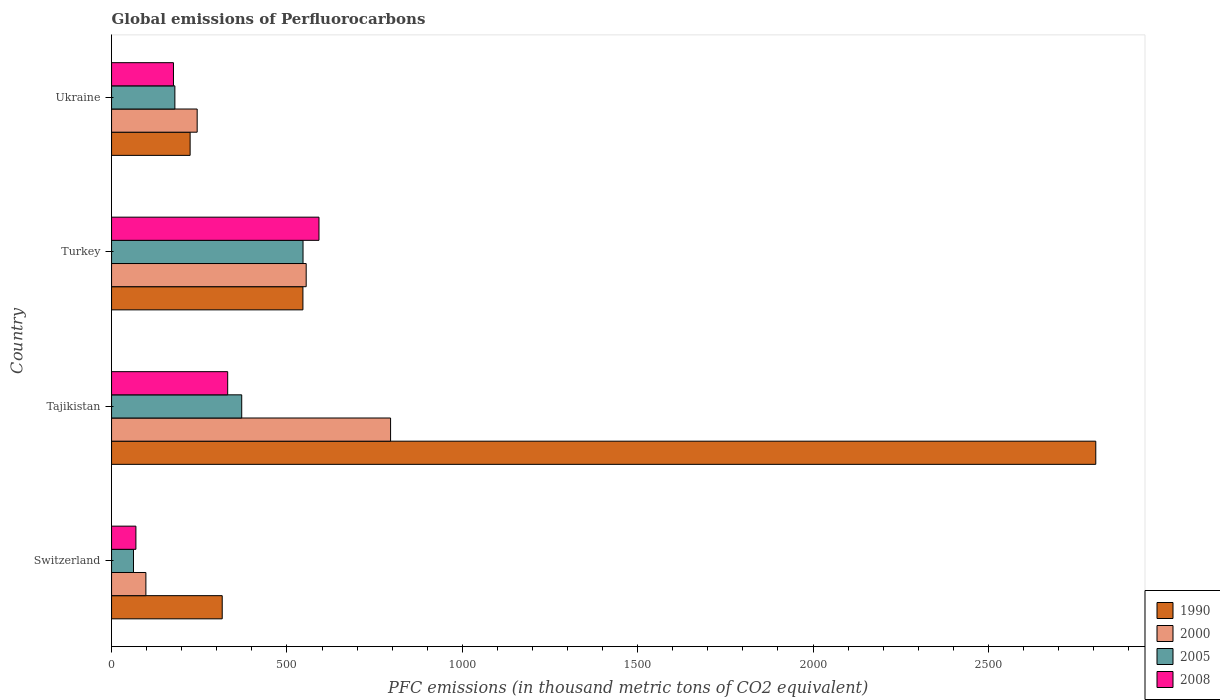How many different coloured bars are there?
Make the answer very short. 4. How many groups of bars are there?
Give a very brief answer. 4. Are the number of bars per tick equal to the number of legend labels?
Give a very brief answer. Yes. How many bars are there on the 1st tick from the bottom?
Offer a very short reply. 4. What is the label of the 4th group of bars from the top?
Ensure brevity in your answer.  Switzerland. In how many cases, is the number of bars for a given country not equal to the number of legend labels?
Offer a terse response. 0. What is the global emissions of Perfluorocarbons in 2005 in Tajikistan?
Make the answer very short. 371.1. Across all countries, what is the maximum global emissions of Perfluorocarbons in 1990?
Your answer should be compact. 2806.1. Across all countries, what is the minimum global emissions of Perfluorocarbons in 2005?
Provide a short and direct response. 62.5. In which country was the global emissions of Perfluorocarbons in 1990 maximum?
Provide a succinct answer. Tajikistan. In which country was the global emissions of Perfluorocarbons in 1990 minimum?
Offer a terse response. Ukraine. What is the total global emissions of Perfluorocarbons in 2008 in the graph?
Provide a short and direct response. 1168.4. What is the difference between the global emissions of Perfluorocarbons in 1990 in Turkey and that in Ukraine?
Offer a very short reply. 321.6. What is the difference between the global emissions of Perfluorocarbons in 1990 in Ukraine and the global emissions of Perfluorocarbons in 2005 in Turkey?
Provide a succinct answer. -321.9. What is the average global emissions of Perfluorocarbons in 2000 per country?
Provide a short and direct response. 423.1. What is the difference between the global emissions of Perfluorocarbons in 2005 and global emissions of Perfluorocarbons in 1990 in Turkey?
Offer a very short reply. 0.3. What is the ratio of the global emissions of Perfluorocarbons in 2000 in Switzerland to that in Ukraine?
Your answer should be compact. 0.4. Is the global emissions of Perfluorocarbons in 2005 in Switzerland less than that in Tajikistan?
Give a very brief answer. Yes. What is the difference between the highest and the second highest global emissions of Perfluorocarbons in 2008?
Your response must be concise. 260.3. What is the difference between the highest and the lowest global emissions of Perfluorocarbons in 2008?
Make the answer very short. 522. Is the sum of the global emissions of Perfluorocarbons in 1990 in Switzerland and Ukraine greater than the maximum global emissions of Perfluorocarbons in 2005 across all countries?
Provide a short and direct response. No. What does the 1st bar from the top in Turkey represents?
Your answer should be compact. 2008. Is it the case that in every country, the sum of the global emissions of Perfluorocarbons in 2000 and global emissions of Perfluorocarbons in 2008 is greater than the global emissions of Perfluorocarbons in 2005?
Your answer should be compact. Yes. How many bars are there?
Your answer should be very brief. 16. How many countries are there in the graph?
Give a very brief answer. 4. Does the graph contain grids?
Provide a short and direct response. No. Where does the legend appear in the graph?
Provide a short and direct response. Bottom right. How are the legend labels stacked?
Offer a very short reply. Vertical. What is the title of the graph?
Provide a succinct answer. Global emissions of Perfluorocarbons. What is the label or title of the X-axis?
Your answer should be compact. PFC emissions (in thousand metric tons of CO2 equivalent). What is the label or title of the Y-axis?
Ensure brevity in your answer.  Country. What is the PFC emissions (in thousand metric tons of CO2 equivalent) of 1990 in Switzerland?
Offer a very short reply. 315.5. What is the PFC emissions (in thousand metric tons of CO2 equivalent) of 2000 in Switzerland?
Make the answer very short. 97.9. What is the PFC emissions (in thousand metric tons of CO2 equivalent) in 2005 in Switzerland?
Provide a short and direct response. 62.5. What is the PFC emissions (in thousand metric tons of CO2 equivalent) in 2008 in Switzerland?
Your response must be concise. 69.4. What is the PFC emissions (in thousand metric tons of CO2 equivalent) of 1990 in Tajikistan?
Your answer should be very brief. 2806.1. What is the PFC emissions (in thousand metric tons of CO2 equivalent) in 2000 in Tajikistan?
Provide a succinct answer. 795.5. What is the PFC emissions (in thousand metric tons of CO2 equivalent) in 2005 in Tajikistan?
Make the answer very short. 371.1. What is the PFC emissions (in thousand metric tons of CO2 equivalent) in 2008 in Tajikistan?
Keep it short and to the point. 331.1. What is the PFC emissions (in thousand metric tons of CO2 equivalent) of 1990 in Turkey?
Provide a succinct answer. 545.6. What is the PFC emissions (in thousand metric tons of CO2 equivalent) of 2000 in Turkey?
Ensure brevity in your answer.  554.9. What is the PFC emissions (in thousand metric tons of CO2 equivalent) in 2005 in Turkey?
Provide a succinct answer. 545.9. What is the PFC emissions (in thousand metric tons of CO2 equivalent) of 2008 in Turkey?
Provide a short and direct response. 591.4. What is the PFC emissions (in thousand metric tons of CO2 equivalent) in 1990 in Ukraine?
Keep it short and to the point. 224. What is the PFC emissions (in thousand metric tons of CO2 equivalent) in 2000 in Ukraine?
Keep it short and to the point. 244.1. What is the PFC emissions (in thousand metric tons of CO2 equivalent) of 2005 in Ukraine?
Offer a very short reply. 180.5. What is the PFC emissions (in thousand metric tons of CO2 equivalent) of 2008 in Ukraine?
Your answer should be very brief. 176.5. Across all countries, what is the maximum PFC emissions (in thousand metric tons of CO2 equivalent) of 1990?
Provide a succinct answer. 2806.1. Across all countries, what is the maximum PFC emissions (in thousand metric tons of CO2 equivalent) in 2000?
Make the answer very short. 795.5. Across all countries, what is the maximum PFC emissions (in thousand metric tons of CO2 equivalent) of 2005?
Keep it short and to the point. 545.9. Across all countries, what is the maximum PFC emissions (in thousand metric tons of CO2 equivalent) of 2008?
Offer a terse response. 591.4. Across all countries, what is the minimum PFC emissions (in thousand metric tons of CO2 equivalent) in 1990?
Offer a terse response. 224. Across all countries, what is the minimum PFC emissions (in thousand metric tons of CO2 equivalent) in 2000?
Make the answer very short. 97.9. Across all countries, what is the minimum PFC emissions (in thousand metric tons of CO2 equivalent) in 2005?
Keep it short and to the point. 62.5. Across all countries, what is the minimum PFC emissions (in thousand metric tons of CO2 equivalent) of 2008?
Keep it short and to the point. 69.4. What is the total PFC emissions (in thousand metric tons of CO2 equivalent) in 1990 in the graph?
Give a very brief answer. 3891.2. What is the total PFC emissions (in thousand metric tons of CO2 equivalent) in 2000 in the graph?
Your response must be concise. 1692.4. What is the total PFC emissions (in thousand metric tons of CO2 equivalent) in 2005 in the graph?
Your answer should be compact. 1160. What is the total PFC emissions (in thousand metric tons of CO2 equivalent) of 2008 in the graph?
Provide a succinct answer. 1168.4. What is the difference between the PFC emissions (in thousand metric tons of CO2 equivalent) in 1990 in Switzerland and that in Tajikistan?
Provide a short and direct response. -2490.6. What is the difference between the PFC emissions (in thousand metric tons of CO2 equivalent) of 2000 in Switzerland and that in Tajikistan?
Offer a very short reply. -697.6. What is the difference between the PFC emissions (in thousand metric tons of CO2 equivalent) of 2005 in Switzerland and that in Tajikistan?
Your answer should be very brief. -308.6. What is the difference between the PFC emissions (in thousand metric tons of CO2 equivalent) in 2008 in Switzerland and that in Tajikistan?
Make the answer very short. -261.7. What is the difference between the PFC emissions (in thousand metric tons of CO2 equivalent) of 1990 in Switzerland and that in Turkey?
Make the answer very short. -230.1. What is the difference between the PFC emissions (in thousand metric tons of CO2 equivalent) in 2000 in Switzerland and that in Turkey?
Provide a succinct answer. -457. What is the difference between the PFC emissions (in thousand metric tons of CO2 equivalent) in 2005 in Switzerland and that in Turkey?
Make the answer very short. -483.4. What is the difference between the PFC emissions (in thousand metric tons of CO2 equivalent) of 2008 in Switzerland and that in Turkey?
Give a very brief answer. -522. What is the difference between the PFC emissions (in thousand metric tons of CO2 equivalent) of 1990 in Switzerland and that in Ukraine?
Provide a short and direct response. 91.5. What is the difference between the PFC emissions (in thousand metric tons of CO2 equivalent) in 2000 in Switzerland and that in Ukraine?
Give a very brief answer. -146.2. What is the difference between the PFC emissions (in thousand metric tons of CO2 equivalent) of 2005 in Switzerland and that in Ukraine?
Give a very brief answer. -118. What is the difference between the PFC emissions (in thousand metric tons of CO2 equivalent) of 2008 in Switzerland and that in Ukraine?
Your response must be concise. -107.1. What is the difference between the PFC emissions (in thousand metric tons of CO2 equivalent) of 1990 in Tajikistan and that in Turkey?
Keep it short and to the point. 2260.5. What is the difference between the PFC emissions (in thousand metric tons of CO2 equivalent) in 2000 in Tajikistan and that in Turkey?
Make the answer very short. 240.6. What is the difference between the PFC emissions (in thousand metric tons of CO2 equivalent) of 2005 in Tajikistan and that in Turkey?
Give a very brief answer. -174.8. What is the difference between the PFC emissions (in thousand metric tons of CO2 equivalent) of 2008 in Tajikistan and that in Turkey?
Make the answer very short. -260.3. What is the difference between the PFC emissions (in thousand metric tons of CO2 equivalent) in 1990 in Tajikistan and that in Ukraine?
Provide a short and direct response. 2582.1. What is the difference between the PFC emissions (in thousand metric tons of CO2 equivalent) in 2000 in Tajikistan and that in Ukraine?
Offer a very short reply. 551.4. What is the difference between the PFC emissions (in thousand metric tons of CO2 equivalent) in 2005 in Tajikistan and that in Ukraine?
Your answer should be very brief. 190.6. What is the difference between the PFC emissions (in thousand metric tons of CO2 equivalent) of 2008 in Tajikistan and that in Ukraine?
Make the answer very short. 154.6. What is the difference between the PFC emissions (in thousand metric tons of CO2 equivalent) of 1990 in Turkey and that in Ukraine?
Your answer should be compact. 321.6. What is the difference between the PFC emissions (in thousand metric tons of CO2 equivalent) of 2000 in Turkey and that in Ukraine?
Offer a very short reply. 310.8. What is the difference between the PFC emissions (in thousand metric tons of CO2 equivalent) of 2005 in Turkey and that in Ukraine?
Keep it short and to the point. 365.4. What is the difference between the PFC emissions (in thousand metric tons of CO2 equivalent) in 2008 in Turkey and that in Ukraine?
Keep it short and to the point. 414.9. What is the difference between the PFC emissions (in thousand metric tons of CO2 equivalent) in 1990 in Switzerland and the PFC emissions (in thousand metric tons of CO2 equivalent) in 2000 in Tajikistan?
Your answer should be very brief. -480. What is the difference between the PFC emissions (in thousand metric tons of CO2 equivalent) of 1990 in Switzerland and the PFC emissions (in thousand metric tons of CO2 equivalent) of 2005 in Tajikistan?
Offer a terse response. -55.6. What is the difference between the PFC emissions (in thousand metric tons of CO2 equivalent) of 1990 in Switzerland and the PFC emissions (in thousand metric tons of CO2 equivalent) of 2008 in Tajikistan?
Provide a succinct answer. -15.6. What is the difference between the PFC emissions (in thousand metric tons of CO2 equivalent) of 2000 in Switzerland and the PFC emissions (in thousand metric tons of CO2 equivalent) of 2005 in Tajikistan?
Offer a terse response. -273.2. What is the difference between the PFC emissions (in thousand metric tons of CO2 equivalent) in 2000 in Switzerland and the PFC emissions (in thousand metric tons of CO2 equivalent) in 2008 in Tajikistan?
Ensure brevity in your answer.  -233.2. What is the difference between the PFC emissions (in thousand metric tons of CO2 equivalent) in 2005 in Switzerland and the PFC emissions (in thousand metric tons of CO2 equivalent) in 2008 in Tajikistan?
Make the answer very short. -268.6. What is the difference between the PFC emissions (in thousand metric tons of CO2 equivalent) in 1990 in Switzerland and the PFC emissions (in thousand metric tons of CO2 equivalent) in 2000 in Turkey?
Offer a very short reply. -239.4. What is the difference between the PFC emissions (in thousand metric tons of CO2 equivalent) of 1990 in Switzerland and the PFC emissions (in thousand metric tons of CO2 equivalent) of 2005 in Turkey?
Your answer should be compact. -230.4. What is the difference between the PFC emissions (in thousand metric tons of CO2 equivalent) in 1990 in Switzerland and the PFC emissions (in thousand metric tons of CO2 equivalent) in 2008 in Turkey?
Give a very brief answer. -275.9. What is the difference between the PFC emissions (in thousand metric tons of CO2 equivalent) in 2000 in Switzerland and the PFC emissions (in thousand metric tons of CO2 equivalent) in 2005 in Turkey?
Your answer should be compact. -448. What is the difference between the PFC emissions (in thousand metric tons of CO2 equivalent) of 2000 in Switzerland and the PFC emissions (in thousand metric tons of CO2 equivalent) of 2008 in Turkey?
Provide a succinct answer. -493.5. What is the difference between the PFC emissions (in thousand metric tons of CO2 equivalent) in 2005 in Switzerland and the PFC emissions (in thousand metric tons of CO2 equivalent) in 2008 in Turkey?
Your answer should be very brief. -528.9. What is the difference between the PFC emissions (in thousand metric tons of CO2 equivalent) of 1990 in Switzerland and the PFC emissions (in thousand metric tons of CO2 equivalent) of 2000 in Ukraine?
Your answer should be compact. 71.4. What is the difference between the PFC emissions (in thousand metric tons of CO2 equivalent) of 1990 in Switzerland and the PFC emissions (in thousand metric tons of CO2 equivalent) of 2005 in Ukraine?
Ensure brevity in your answer.  135. What is the difference between the PFC emissions (in thousand metric tons of CO2 equivalent) of 1990 in Switzerland and the PFC emissions (in thousand metric tons of CO2 equivalent) of 2008 in Ukraine?
Offer a terse response. 139. What is the difference between the PFC emissions (in thousand metric tons of CO2 equivalent) of 2000 in Switzerland and the PFC emissions (in thousand metric tons of CO2 equivalent) of 2005 in Ukraine?
Your answer should be very brief. -82.6. What is the difference between the PFC emissions (in thousand metric tons of CO2 equivalent) in 2000 in Switzerland and the PFC emissions (in thousand metric tons of CO2 equivalent) in 2008 in Ukraine?
Offer a very short reply. -78.6. What is the difference between the PFC emissions (in thousand metric tons of CO2 equivalent) of 2005 in Switzerland and the PFC emissions (in thousand metric tons of CO2 equivalent) of 2008 in Ukraine?
Your response must be concise. -114. What is the difference between the PFC emissions (in thousand metric tons of CO2 equivalent) of 1990 in Tajikistan and the PFC emissions (in thousand metric tons of CO2 equivalent) of 2000 in Turkey?
Your answer should be very brief. 2251.2. What is the difference between the PFC emissions (in thousand metric tons of CO2 equivalent) in 1990 in Tajikistan and the PFC emissions (in thousand metric tons of CO2 equivalent) in 2005 in Turkey?
Your response must be concise. 2260.2. What is the difference between the PFC emissions (in thousand metric tons of CO2 equivalent) in 1990 in Tajikistan and the PFC emissions (in thousand metric tons of CO2 equivalent) in 2008 in Turkey?
Ensure brevity in your answer.  2214.7. What is the difference between the PFC emissions (in thousand metric tons of CO2 equivalent) of 2000 in Tajikistan and the PFC emissions (in thousand metric tons of CO2 equivalent) of 2005 in Turkey?
Your answer should be very brief. 249.6. What is the difference between the PFC emissions (in thousand metric tons of CO2 equivalent) in 2000 in Tajikistan and the PFC emissions (in thousand metric tons of CO2 equivalent) in 2008 in Turkey?
Your answer should be very brief. 204.1. What is the difference between the PFC emissions (in thousand metric tons of CO2 equivalent) in 2005 in Tajikistan and the PFC emissions (in thousand metric tons of CO2 equivalent) in 2008 in Turkey?
Your answer should be compact. -220.3. What is the difference between the PFC emissions (in thousand metric tons of CO2 equivalent) of 1990 in Tajikistan and the PFC emissions (in thousand metric tons of CO2 equivalent) of 2000 in Ukraine?
Your answer should be very brief. 2562. What is the difference between the PFC emissions (in thousand metric tons of CO2 equivalent) of 1990 in Tajikistan and the PFC emissions (in thousand metric tons of CO2 equivalent) of 2005 in Ukraine?
Provide a succinct answer. 2625.6. What is the difference between the PFC emissions (in thousand metric tons of CO2 equivalent) in 1990 in Tajikistan and the PFC emissions (in thousand metric tons of CO2 equivalent) in 2008 in Ukraine?
Provide a short and direct response. 2629.6. What is the difference between the PFC emissions (in thousand metric tons of CO2 equivalent) of 2000 in Tajikistan and the PFC emissions (in thousand metric tons of CO2 equivalent) of 2005 in Ukraine?
Keep it short and to the point. 615. What is the difference between the PFC emissions (in thousand metric tons of CO2 equivalent) of 2000 in Tajikistan and the PFC emissions (in thousand metric tons of CO2 equivalent) of 2008 in Ukraine?
Offer a very short reply. 619. What is the difference between the PFC emissions (in thousand metric tons of CO2 equivalent) of 2005 in Tajikistan and the PFC emissions (in thousand metric tons of CO2 equivalent) of 2008 in Ukraine?
Your answer should be very brief. 194.6. What is the difference between the PFC emissions (in thousand metric tons of CO2 equivalent) in 1990 in Turkey and the PFC emissions (in thousand metric tons of CO2 equivalent) in 2000 in Ukraine?
Ensure brevity in your answer.  301.5. What is the difference between the PFC emissions (in thousand metric tons of CO2 equivalent) of 1990 in Turkey and the PFC emissions (in thousand metric tons of CO2 equivalent) of 2005 in Ukraine?
Offer a very short reply. 365.1. What is the difference between the PFC emissions (in thousand metric tons of CO2 equivalent) in 1990 in Turkey and the PFC emissions (in thousand metric tons of CO2 equivalent) in 2008 in Ukraine?
Your answer should be compact. 369.1. What is the difference between the PFC emissions (in thousand metric tons of CO2 equivalent) of 2000 in Turkey and the PFC emissions (in thousand metric tons of CO2 equivalent) of 2005 in Ukraine?
Give a very brief answer. 374.4. What is the difference between the PFC emissions (in thousand metric tons of CO2 equivalent) in 2000 in Turkey and the PFC emissions (in thousand metric tons of CO2 equivalent) in 2008 in Ukraine?
Give a very brief answer. 378.4. What is the difference between the PFC emissions (in thousand metric tons of CO2 equivalent) in 2005 in Turkey and the PFC emissions (in thousand metric tons of CO2 equivalent) in 2008 in Ukraine?
Your response must be concise. 369.4. What is the average PFC emissions (in thousand metric tons of CO2 equivalent) of 1990 per country?
Keep it short and to the point. 972.8. What is the average PFC emissions (in thousand metric tons of CO2 equivalent) of 2000 per country?
Your answer should be very brief. 423.1. What is the average PFC emissions (in thousand metric tons of CO2 equivalent) in 2005 per country?
Offer a very short reply. 290. What is the average PFC emissions (in thousand metric tons of CO2 equivalent) of 2008 per country?
Give a very brief answer. 292.1. What is the difference between the PFC emissions (in thousand metric tons of CO2 equivalent) in 1990 and PFC emissions (in thousand metric tons of CO2 equivalent) in 2000 in Switzerland?
Offer a very short reply. 217.6. What is the difference between the PFC emissions (in thousand metric tons of CO2 equivalent) of 1990 and PFC emissions (in thousand metric tons of CO2 equivalent) of 2005 in Switzerland?
Your answer should be very brief. 253. What is the difference between the PFC emissions (in thousand metric tons of CO2 equivalent) in 1990 and PFC emissions (in thousand metric tons of CO2 equivalent) in 2008 in Switzerland?
Provide a short and direct response. 246.1. What is the difference between the PFC emissions (in thousand metric tons of CO2 equivalent) of 2000 and PFC emissions (in thousand metric tons of CO2 equivalent) of 2005 in Switzerland?
Provide a short and direct response. 35.4. What is the difference between the PFC emissions (in thousand metric tons of CO2 equivalent) of 2005 and PFC emissions (in thousand metric tons of CO2 equivalent) of 2008 in Switzerland?
Your response must be concise. -6.9. What is the difference between the PFC emissions (in thousand metric tons of CO2 equivalent) of 1990 and PFC emissions (in thousand metric tons of CO2 equivalent) of 2000 in Tajikistan?
Your answer should be compact. 2010.6. What is the difference between the PFC emissions (in thousand metric tons of CO2 equivalent) in 1990 and PFC emissions (in thousand metric tons of CO2 equivalent) in 2005 in Tajikistan?
Offer a terse response. 2435. What is the difference between the PFC emissions (in thousand metric tons of CO2 equivalent) of 1990 and PFC emissions (in thousand metric tons of CO2 equivalent) of 2008 in Tajikistan?
Give a very brief answer. 2475. What is the difference between the PFC emissions (in thousand metric tons of CO2 equivalent) in 2000 and PFC emissions (in thousand metric tons of CO2 equivalent) in 2005 in Tajikistan?
Give a very brief answer. 424.4. What is the difference between the PFC emissions (in thousand metric tons of CO2 equivalent) in 2000 and PFC emissions (in thousand metric tons of CO2 equivalent) in 2008 in Tajikistan?
Offer a terse response. 464.4. What is the difference between the PFC emissions (in thousand metric tons of CO2 equivalent) of 1990 and PFC emissions (in thousand metric tons of CO2 equivalent) of 2005 in Turkey?
Your answer should be very brief. -0.3. What is the difference between the PFC emissions (in thousand metric tons of CO2 equivalent) in 1990 and PFC emissions (in thousand metric tons of CO2 equivalent) in 2008 in Turkey?
Keep it short and to the point. -45.8. What is the difference between the PFC emissions (in thousand metric tons of CO2 equivalent) in 2000 and PFC emissions (in thousand metric tons of CO2 equivalent) in 2005 in Turkey?
Your answer should be very brief. 9. What is the difference between the PFC emissions (in thousand metric tons of CO2 equivalent) in 2000 and PFC emissions (in thousand metric tons of CO2 equivalent) in 2008 in Turkey?
Provide a short and direct response. -36.5. What is the difference between the PFC emissions (in thousand metric tons of CO2 equivalent) of 2005 and PFC emissions (in thousand metric tons of CO2 equivalent) of 2008 in Turkey?
Keep it short and to the point. -45.5. What is the difference between the PFC emissions (in thousand metric tons of CO2 equivalent) of 1990 and PFC emissions (in thousand metric tons of CO2 equivalent) of 2000 in Ukraine?
Your answer should be compact. -20.1. What is the difference between the PFC emissions (in thousand metric tons of CO2 equivalent) in 1990 and PFC emissions (in thousand metric tons of CO2 equivalent) in 2005 in Ukraine?
Your answer should be very brief. 43.5. What is the difference between the PFC emissions (in thousand metric tons of CO2 equivalent) of 1990 and PFC emissions (in thousand metric tons of CO2 equivalent) of 2008 in Ukraine?
Keep it short and to the point. 47.5. What is the difference between the PFC emissions (in thousand metric tons of CO2 equivalent) in 2000 and PFC emissions (in thousand metric tons of CO2 equivalent) in 2005 in Ukraine?
Make the answer very short. 63.6. What is the difference between the PFC emissions (in thousand metric tons of CO2 equivalent) of 2000 and PFC emissions (in thousand metric tons of CO2 equivalent) of 2008 in Ukraine?
Offer a very short reply. 67.6. What is the ratio of the PFC emissions (in thousand metric tons of CO2 equivalent) of 1990 in Switzerland to that in Tajikistan?
Ensure brevity in your answer.  0.11. What is the ratio of the PFC emissions (in thousand metric tons of CO2 equivalent) of 2000 in Switzerland to that in Tajikistan?
Your answer should be very brief. 0.12. What is the ratio of the PFC emissions (in thousand metric tons of CO2 equivalent) of 2005 in Switzerland to that in Tajikistan?
Offer a terse response. 0.17. What is the ratio of the PFC emissions (in thousand metric tons of CO2 equivalent) in 2008 in Switzerland to that in Tajikistan?
Make the answer very short. 0.21. What is the ratio of the PFC emissions (in thousand metric tons of CO2 equivalent) of 1990 in Switzerland to that in Turkey?
Your response must be concise. 0.58. What is the ratio of the PFC emissions (in thousand metric tons of CO2 equivalent) in 2000 in Switzerland to that in Turkey?
Your answer should be compact. 0.18. What is the ratio of the PFC emissions (in thousand metric tons of CO2 equivalent) of 2005 in Switzerland to that in Turkey?
Give a very brief answer. 0.11. What is the ratio of the PFC emissions (in thousand metric tons of CO2 equivalent) of 2008 in Switzerland to that in Turkey?
Your answer should be very brief. 0.12. What is the ratio of the PFC emissions (in thousand metric tons of CO2 equivalent) of 1990 in Switzerland to that in Ukraine?
Keep it short and to the point. 1.41. What is the ratio of the PFC emissions (in thousand metric tons of CO2 equivalent) of 2000 in Switzerland to that in Ukraine?
Provide a short and direct response. 0.4. What is the ratio of the PFC emissions (in thousand metric tons of CO2 equivalent) in 2005 in Switzerland to that in Ukraine?
Your response must be concise. 0.35. What is the ratio of the PFC emissions (in thousand metric tons of CO2 equivalent) in 2008 in Switzerland to that in Ukraine?
Your response must be concise. 0.39. What is the ratio of the PFC emissions (in thousand metric tons of CO2 equivalent) of 1990 in Tajikistan to that in Turkey?
Provide a short and direct response. 5.14. What is the ratio of the PFC emissions (in thousand metric tons of CO2 equivalent) of 2000 in Tajikistan to that in Turkey?
Make the answer very short. 1.43. What is the ratio of the PFC emissions (in thousand metric tons of CO2 equivalent) of 2005 in Tajikistan to that in Turkey?
Keep it short and to the point. 0.68. What is the ratio of the PFC emissions (in thousand metric tons of CO2 equivalent) of 2008 in Tajikistan to that in Turkey?
Make the answer very short. 0.56. What is the ratio of the PFC emissions (in thousand metric tons of CO2 equivalent) of 1990 in Tajikistan to that in Ukraine?
Offer a terse response. 12.53. What is the ratio of the PFC emissions (in thousand metric tons of CO2 equivalent) in 2000 in Tajikistan to that in Ukraine?
Provide a succinct answer. 3.26. What is the ratio of the PFC emissions (in thousand metric tons of CO2 equivalent) in 2005 in Tajikistan to that in Ukraine?
Make the answer very short. 2.06. What is the ratio of the PFC emissions (in thousand metric tons of CO2 equivalent) of 2008 in Tajikistan to that in Ukraine?
Your answer should be compact. 1.88. What is the ratio of the PFC emissions (in thousand metric tons of CO2 equivalent) in 1990 in Turkey to that in Ukraine?
Keep it short and to the point. 2.44. What is the ratio of the PFC emissions (in thousand metric tons of CO2 equivalent) in 2000 in Turkey to that in Ukraine?
Your answer should be compact. 2.27. What is the ratio of the PFC emissions (in thousand metric tons of CO2 equivalent) in 2005 in Turkey to that in Ukraine?
Your answer should be very brief. 3.02. What is the ratio of the PFC emissions (in thousand metric tons of CO2 equivalent) of 2008 in Turkey to that in Ukraine?
Ensure brevity in your answer.  3.35. What is the difference between the highest and the second highest PFC emissions (in thousand metric tons of CO2 equivalent) of 1990?
Keep it short and to the point. 2260.5. What is the difference between the highest and the second highest PFC emissions (in thousand metric tons of CO2 equivalent) of 2000?
Offer a terse response. 240.6. What is the difference between the highest and the second highest PFC emissions (in thousand metric tons of CO2 equivalent) in 2005?
Keep it short and to the point. 174.8. What is the difference between the highest and the second highest PFC emissions (in thousand metric tons of CO2 equivalent) of 2008?
Give a very brief answer. 260.3. What is the difference between the highest and the lowest PFC emissions (in thousand metric tons of CO2 equivalent) in 1990?
Your answer should be compact. 2582.1. What is the difference between the highest and the lowest PFC emissions (in thousand metric tons of CO2 equivalent) in 2000?
Make the answer very short. 697.6. What is the difference between the highest and the lowest PFC emissions (in thousand metric tons of CO2 equivalent) of 2005?
Provide a succinct answer. 483.4. What is the difference between the highest and the lowest PFC emissions (in thousand metric tons of CO2 equivalent) in 2008?
Offer a very short reply. 522. 